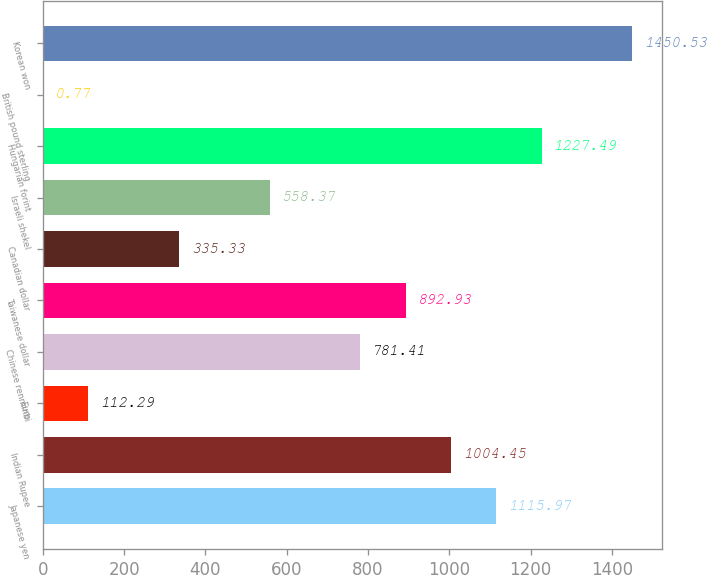Convert chart. <chart><loc_0><loc_0><loc_500><loc_500><bar_chart><fcel>Japanese yen<fcel>Indian Rupee<fcel>Euro<fcel>Chinese renminbi<fcel>Taiwanese dollar<fcel>Canadian dollar<fcel>Israeli shekel<fcel>Hungarian forint<fcel>British pound sterling<fcel>Korean won<nl><fcel>1115.97<fcel>1004.45<fcel>112.29<fcel>781.41<fcel>892.93<fcel>335.33<fcel>558.37<fcel>1227.49<fcel>0.77<fcel>1450.53<nl></chart> 